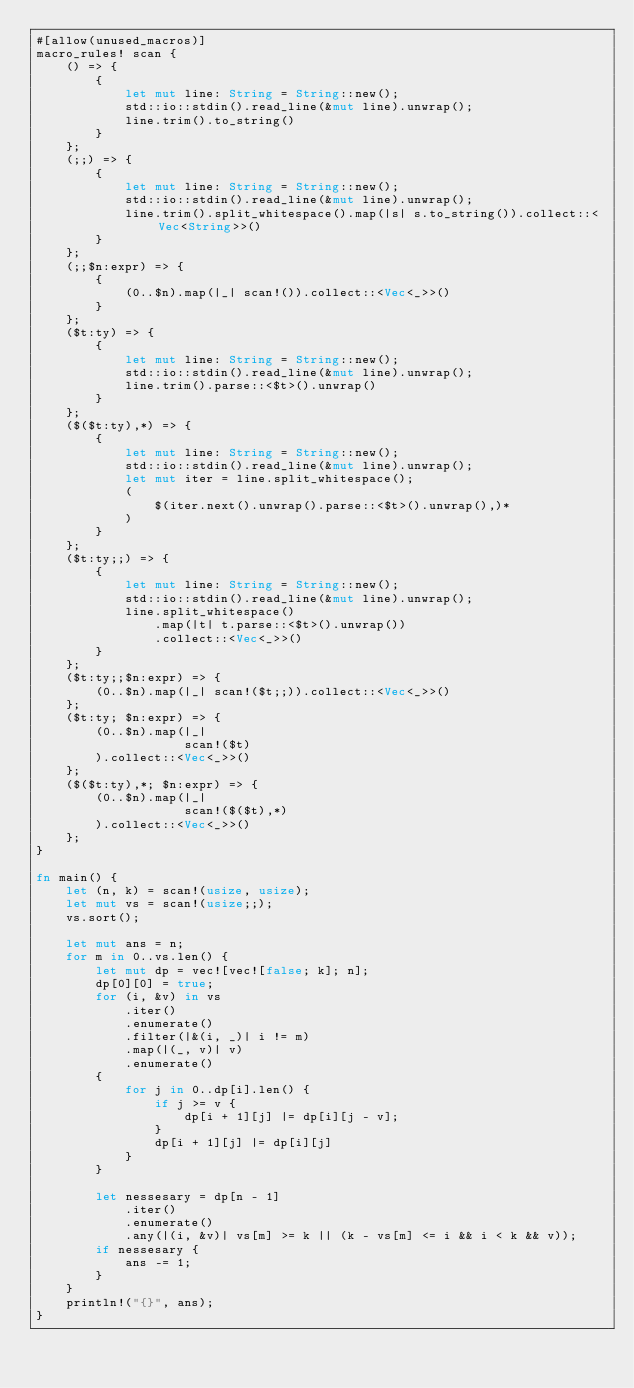Convert code to text. <code><loc_0><loc_0><loc_500><loc_500><_Rust_>#[allow(unused_macros)]
macro_rules! scan {
    () => {
        {
            let mut line: String = String::new();
            std::io::stdin().read_line(&mut line).unwrap();
            line.trim().to_string()
        }
    };
    (;;) => {
        {
            let mut line: String = String::new();
            std::io::stdin().read_line(&mut line).unwrap();
            line.trim().split_whitespace().map(|s| s.to_string()).collect::<Vec<String>>()
        }
    };
    (;;$n:expr) => {
        {
            (0..$n).map(|_| scan!()).collect::<Vec<_>>()
        }
    };
    ($t:ty) => {
        {
            let mut line: String = String::new();
            std::io::stdin().read_line(&mut line).unwrap();
            line.trim().parse::<$t>().unwrap()
        }
    };
    ($($t:ty),*) => {
        {
            let mut line: String = String::new();
            std::io::stdin().read_line(&mut line).unwrap();
            let mut iter = line.split_whitespace();
            (
                $(iter.next().unwrap().parse::<$t>().unwrap(),)*
            )
        }
    };
    ($t:ty;;) => {
        {
            let mut line: String = String::new();
            std::io::stdin().read_line(&mut line).unwrap();
            line.split_whitespace()
                .map(|t| t.parse::<$t>().unwrap())
                .collect::<Vec<_>>()
        }
    };
    ($t:ty;;$n:expr) => {
        (0..$n).map(|_| scan!($t;;)).collect::<Vec<_>>()
    };
    ($t:ty; $n:expr) => {
        (0..$n).map(|_|
                    scan!($t)
        ).collect::<Vec<_>>()
    };
    ($($t:ty),*; $n:expr) => {
        (0..$n).map(|_|
                    scan!($($t),*)
        ).collect::<Vec<_>>()
    };
}

fn main() {
    let (n, k) = scan!(usize, usize);
    let mut vs = scan!(usize;;);
    vs.sort();

    let mut ans = n;
    for m in 0..vs.len() {
        let mut dp = vec![vec![false; k]; n];
        dp[0][0] = true;
        for (i, &v) in vs
            .iter()
            .enumerate()
            .filter(|&(i, _)| i != m)
            .map(|(_, v)| v)
            .enumerate()
        {
            for j in 0..dp[i].len() {
                if j >= v {
                    dp[i + 1][j] |= dp[i][j - v];
                }
                dp[i + 1][j] |= dp[i][j]
            }
        }

        let nessesary = dp[n - 1]
            .iter()
            .enumerate()
            .any(|(i, &v)| vs[m] >= k || (k - vs[m] <= i && i < k && v));
        if nessesary {
            ans -= 1;
        }
    }
    println!("{}", ans);
}
</code> 